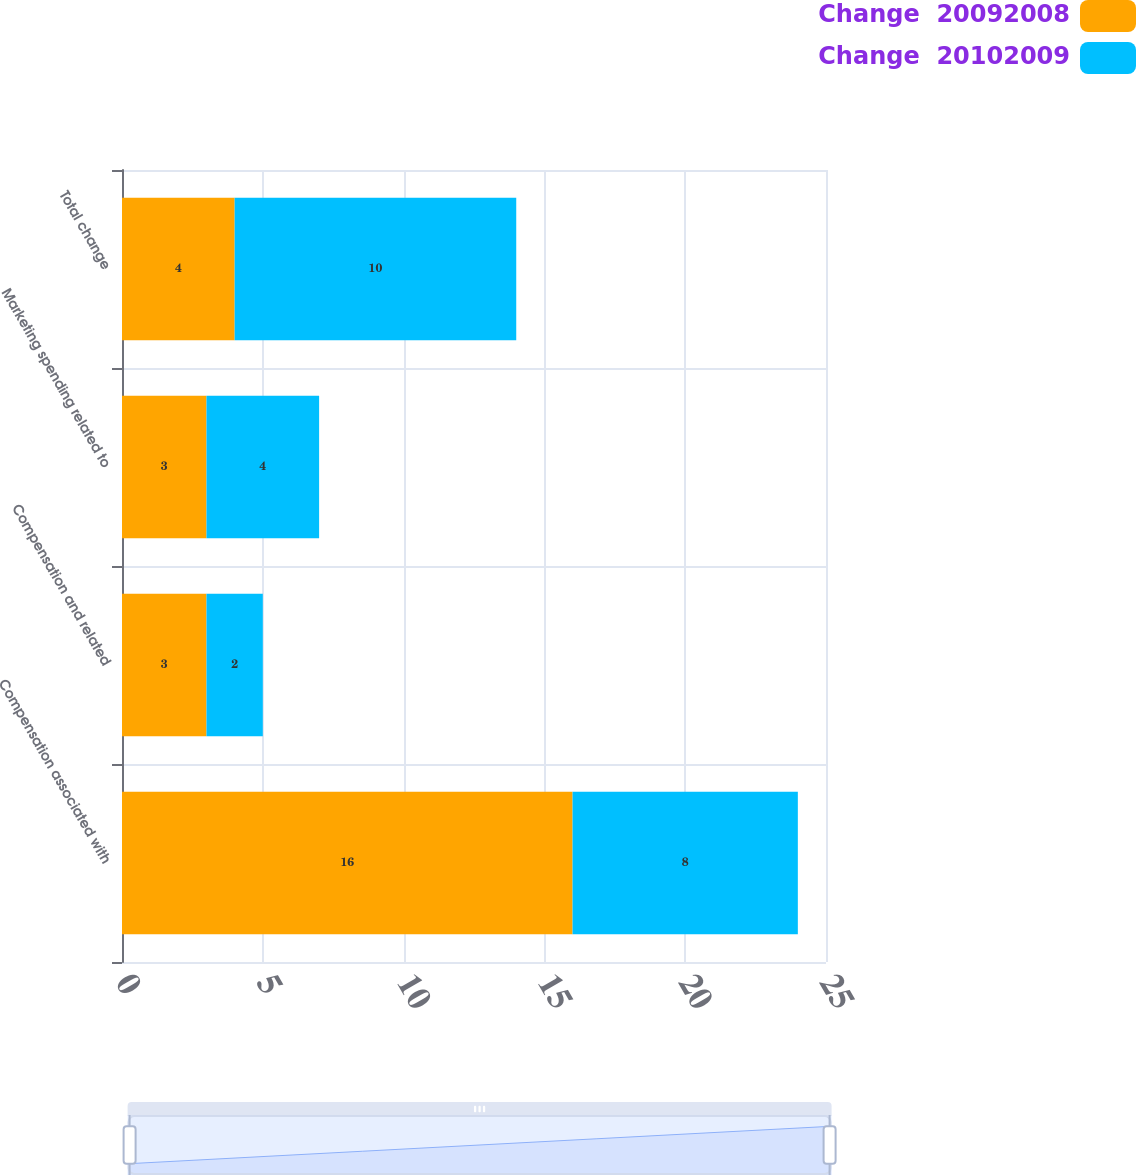<chart> <loc_0><loc_0><loc_500><loc_500><stacked_bar_chart><ecel><fcel>Compensation associated with<fcel>Compensation and related<fcel>Marketing spending related to<fcel>Total change<nl><fcel>Change  20092008<fcel>16<fcel>3<fcel>3<fcel>4<nl><fcel>Change  20102009<fcel>8<fcel>2<fcel>4<fcel>10<nl></chart> 